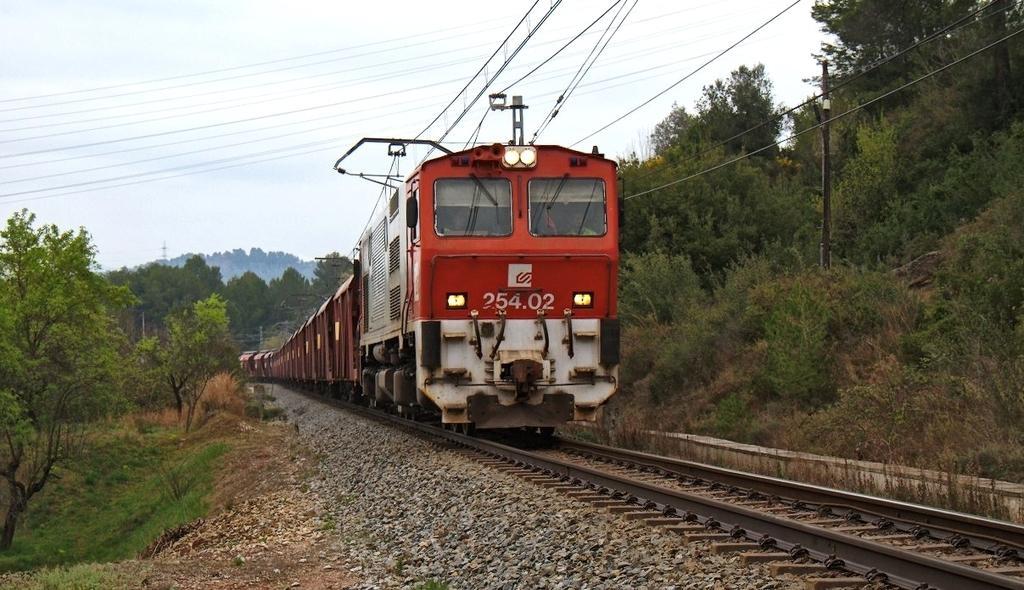Describe this image in one or two sentences. In this image there is a train on the track and we can see trees. There is a pole. In the background there are hills, wires and sky. 